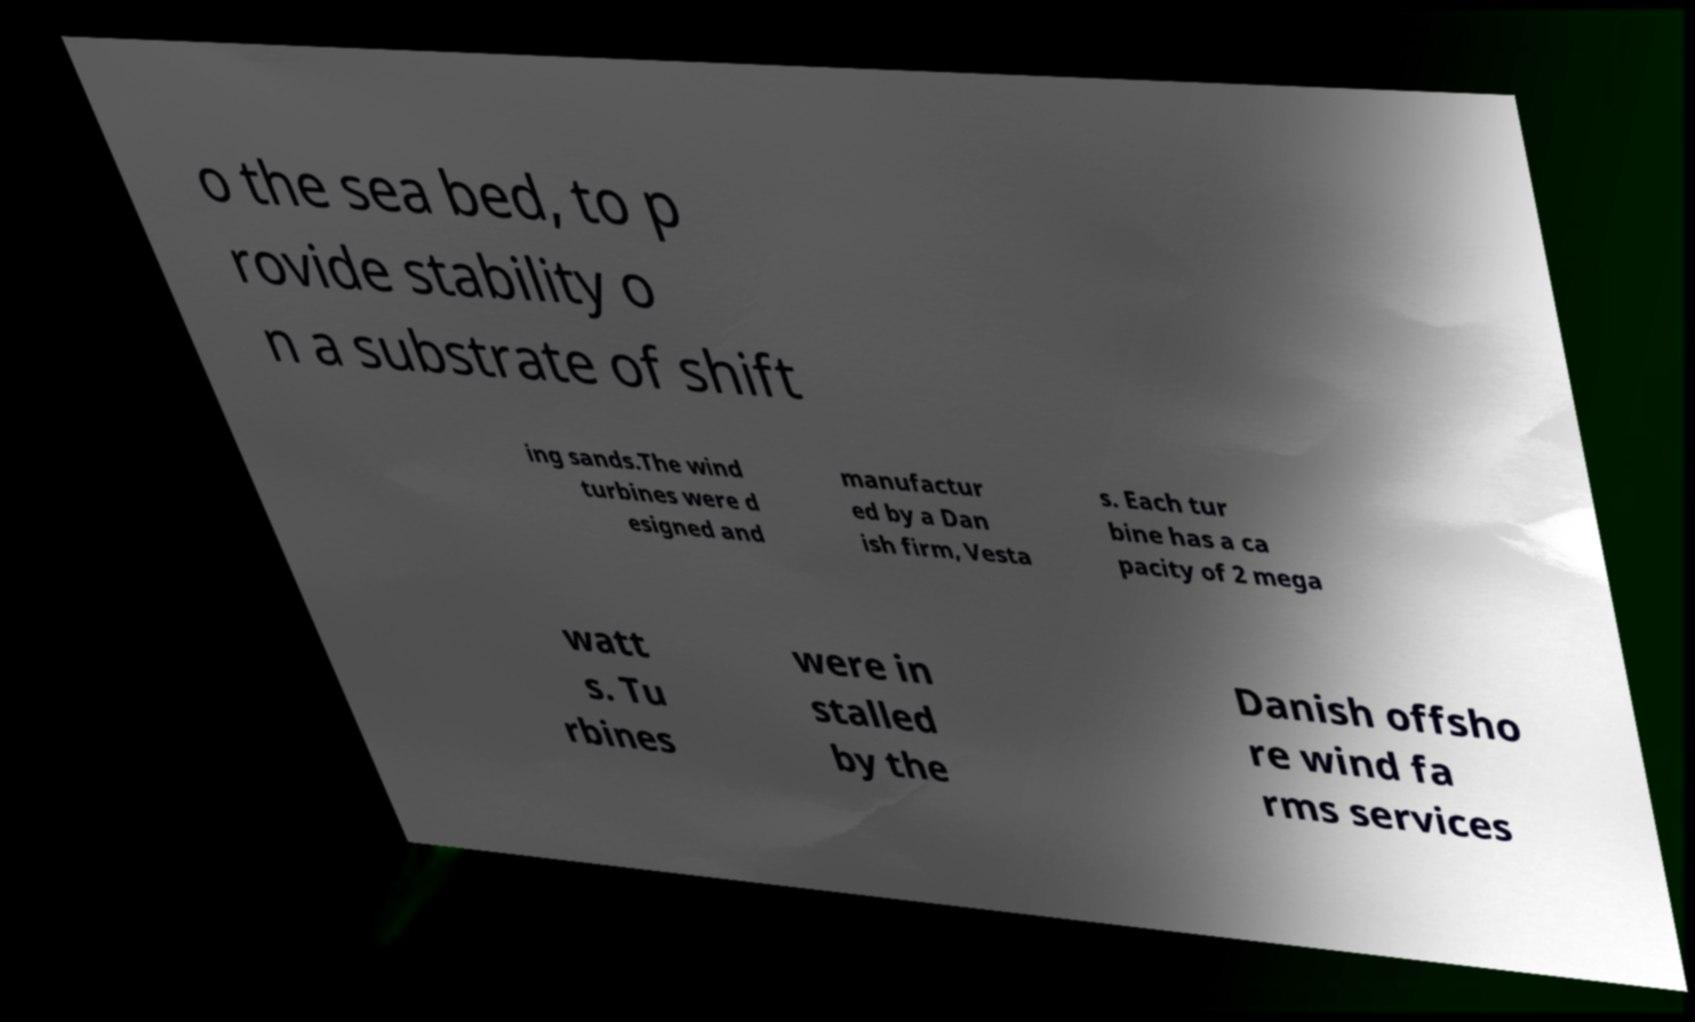Please identify and transcribe the text found in this image. o the sea bed, to p rovide stability o n a substrate of shift ing sands.The wind turbines were d esigned and manufactur ed by a Dan ish firm, Vesta s. Each tur bine has a ca pacity of 2 mega watt s. Tu rbines were in stalled by the Danish offsho re wind fa rms services 